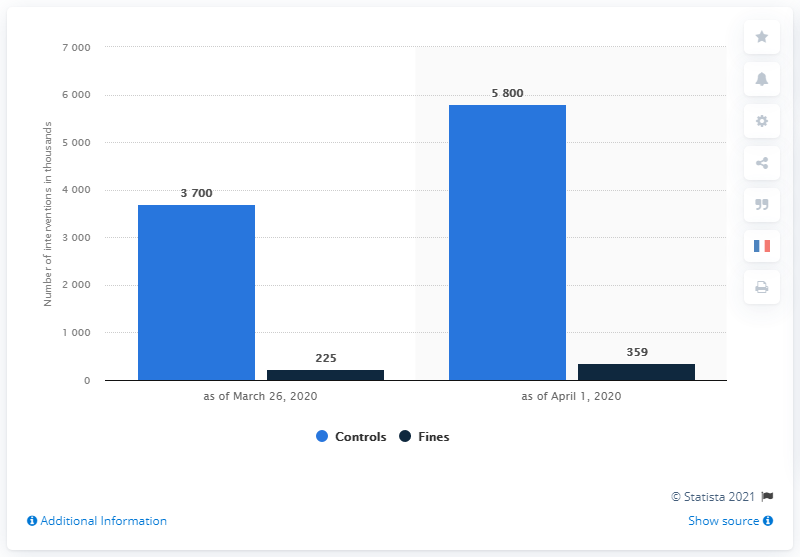List a handful of essential elements in this visual. On April 1, a total of 5800 controls were conducted. 